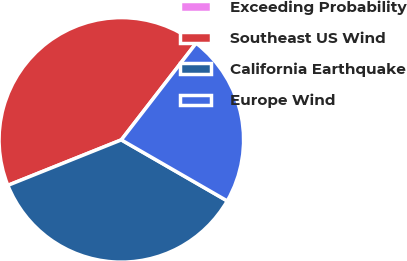<chart> <loc_0><loc_0><loc_500><loc_500><pie_chart><fcel>Exceeding Probability<fcel>Southeast US Wind<fcel>California Earthquake<fcel>Europe Wind<nl><fcel>0.01%<fcel>41.54%<fcel>35.61%<fcel>22.84%<nl></chart> 